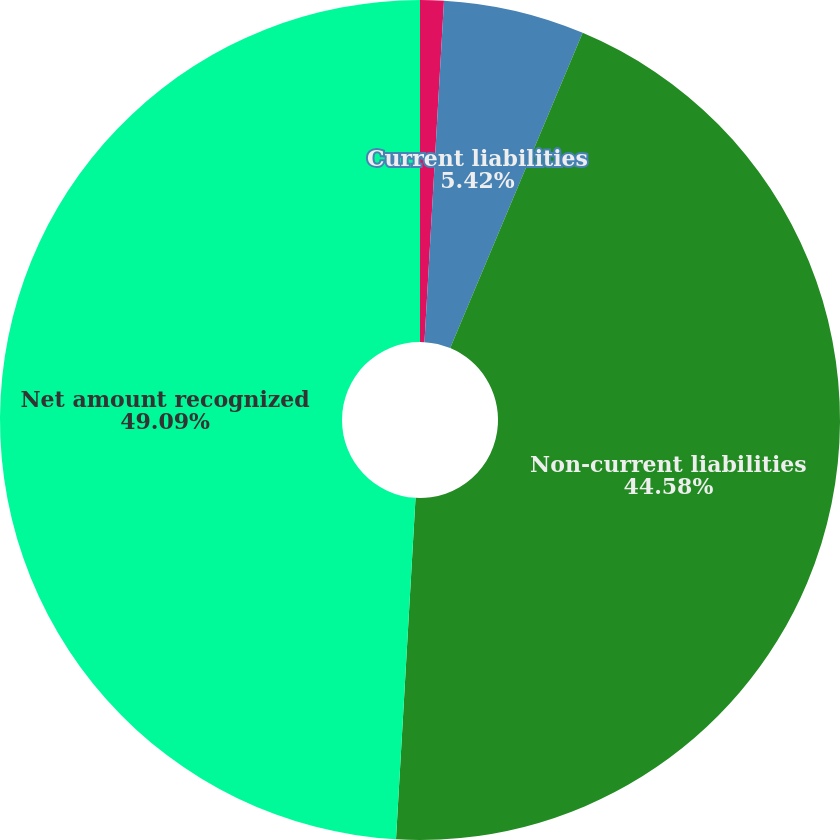Convert chart. <chart><loc_0><loc_0><loc_500><loc_500><pie_chart><fcel>(DOLLARS IN THOUSANDS)<fcel>Current liabilities<fcel>Non-current liabilities<fcel>Net amount recognized<nl><fcel>0.91%<fcel>5.42%<fcel>44.58%<fcel>49.09%<nl></chart> 